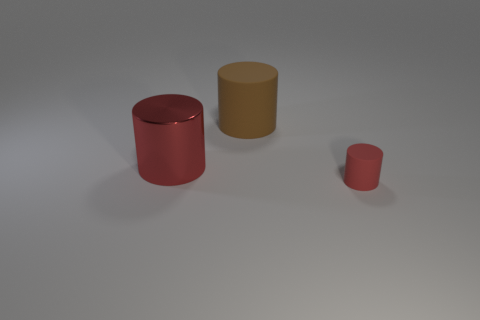There is a large cylinder that is in front of the brown matte object; is its color the same as the small rubber cylinder?
Your response must be concise. Yes. What number of things are either small cylinders or objects that are on the left side of the small object?
Make the answer very short. 3. Is there anything else that has the same color as the large metallic thing?
Your answer should be very brief. Yes. What is the shape of the large brown thing that is the same material as the small object?
Provide a succinct answer. Cylinder. The cylinder that is both to the left of the tiny thing and in front of the brown matte cylinder is made of what material?
Your answer should be very brief. Metal. Is there anything else that is the same size as the red metal cylinder?
Your answer should be compact. Yes. Does the metallic object have the same color as the tiny object?
Give a very brief answer. Yes. There is a object that is the same color as the small cylinder; what shape is it?
Your answer should be compact. Cylinder. How many small green metal things are the same shape as the big metallic thing?
Make the answer very short. 0. What size is the brown cylinder that is the same material as the small red thing?
Ensure brevity in your answer.  Large. 